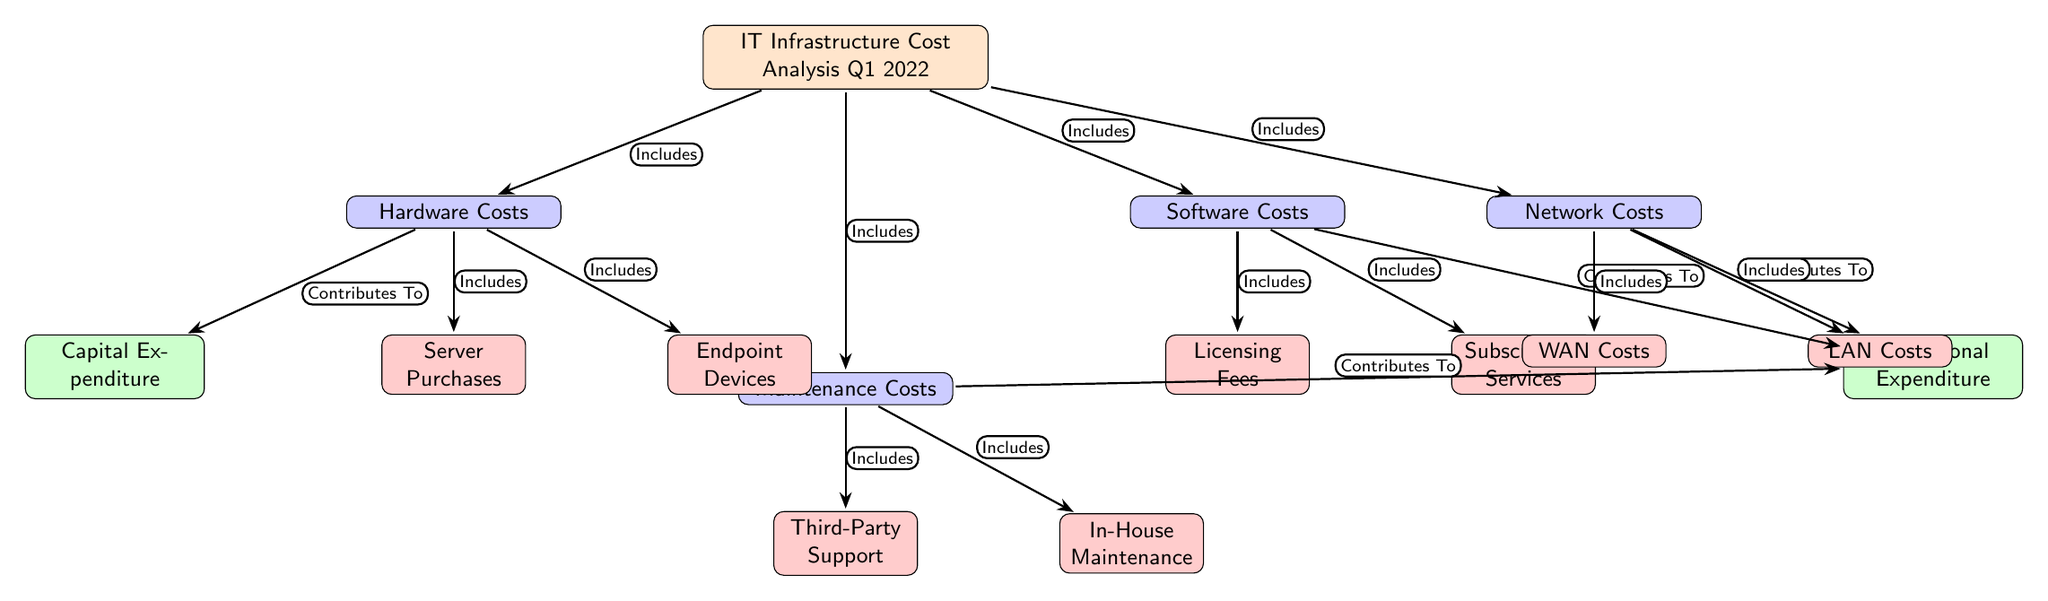What are the main categories of costs in the analysis? The diagram shows four main categories of costs branching from the central node labeled "IT Infrastructure Cost Analysis Q1 2022". These categories are: Hardware Costs, Software Costs, Maintenance Costs, and Network Costs.
Answer: Hardware Costs, Software Costs, Maintenance Costs, Network Costs How many level 2 nodes are present in the diagram? There are two level 2 nodes in the diagram: Capital Expenditure and Operational Expenditure. These nodes connect to various level 1 nodes.
Answer: 2 Which level 1 node includes Server Purchases? The Server Purchases node is included under the Hardware Costs category, as indicated by the arrow connecting the two nodes.
Answer: Hardware Costs What determines operational expenditure costs in the diagram? The Operational Expenditure costs are determined by Software Costs, Maintenance Costs, and Network Costs, as these are all connected to the Operational Expenditure node by contributing arrows.
Answer: Software Costs, Maintenance Costs, Network Costs What is the relationship between Hardware Costs and Capital Expenditure? Hardware Costs contribute to Capital Expenditure, as shown by the arrow labeled “Contributes To” pointing from Hardware Costs to Capital Expenditure in the diagram.
Answer: Contributes To Which costs include Third-Party Support? Third-Party Support is included within the Maintenance Costs category, as indicated by the connection from the Maintenance Costs node to the Third-Party Support node.
Answer: Maintenance Costs 